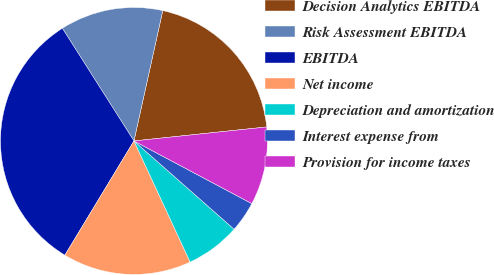<chart> <loc_0><loc_0><loc_500><loc_500><pie_chart><fcel>Decision Analytics EBITDA<fcel>Risk Assessment EBITDA<fcel>EBITDA<fcel>Net income<fcel>Depreciation and amortization<fcel>Interest expense from<fcel>Provision for income taxes<nl><fcel>19.87%<fcel>12.47%<fcel>32.34%<fcel>15.57%<fcel>6.59%<fcel>3.72%<fcel>9.45%<nl></chart> 